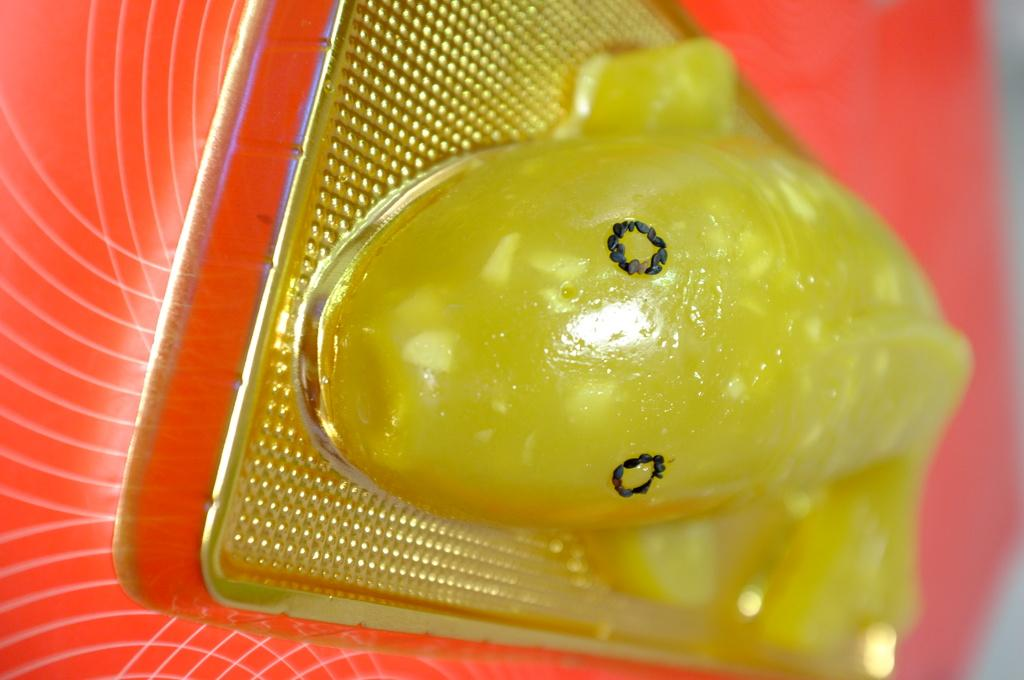What is the main subject of the image? There is a depiction of a fish in the image. Where is the fish located in the image? The fish is depicted on a table. How is the table positioned in the image? The table is in the center of the image. What type of interest does the fish have in the image? The image does not depict the fish having any interest, as it is a static representation of a fish on a table. 